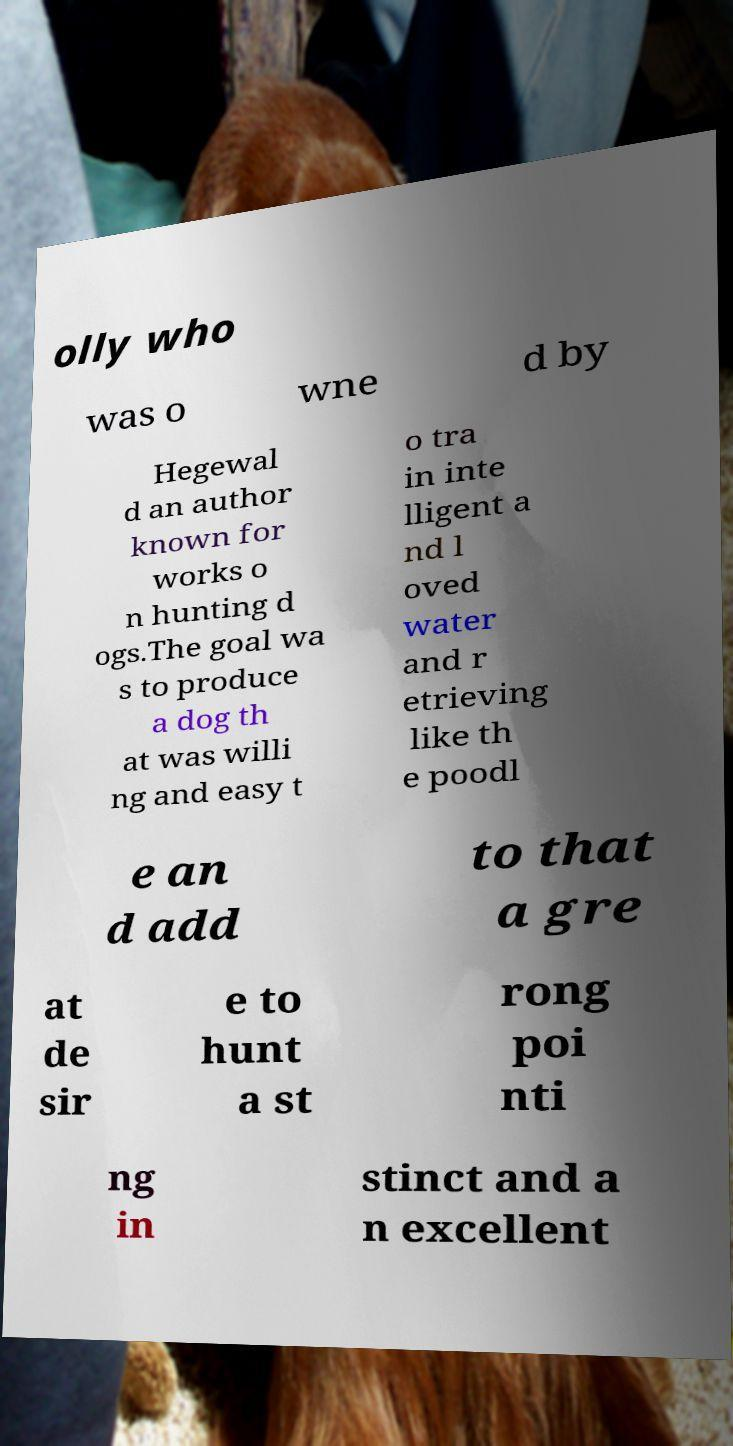Could you extract and type out the text from this image? olly who was o wne d by Hegewal d an author known for works o n hunting d ogs.The goal wa s to produce a dog th at was willi ng and easy t o tra in inte lligent a nd l oved water and r etrieving like th e poodl e an d add to that a gre at de sir e to hunt a st rong poi nti ng in stinct and a n excellent 